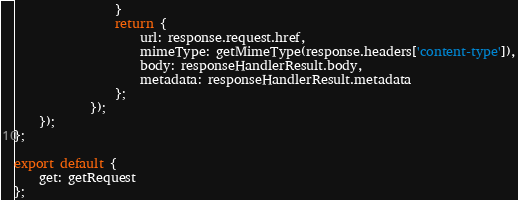Convert code to text. <code><loc_0><loc_0><loc_500><loc_500><_JavaScript_>				}
				return {
					url: response.request.href,
					mimeType: getMimeType(response.headers['content-type']),
					body: responseHandlerResult.body,
					metadata: responseHandlerResult.metadata
				};
			});
	});
};

export default {
	get: getRequest
};
</code> 